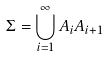Convert formula to latex. <formula><loc_0><loc_0><loc_500><loc_500>\Sigma = \bigcup _ { i = 1 } ^ { \infty } A _ { i } A _ { i + 1 }</formula> 